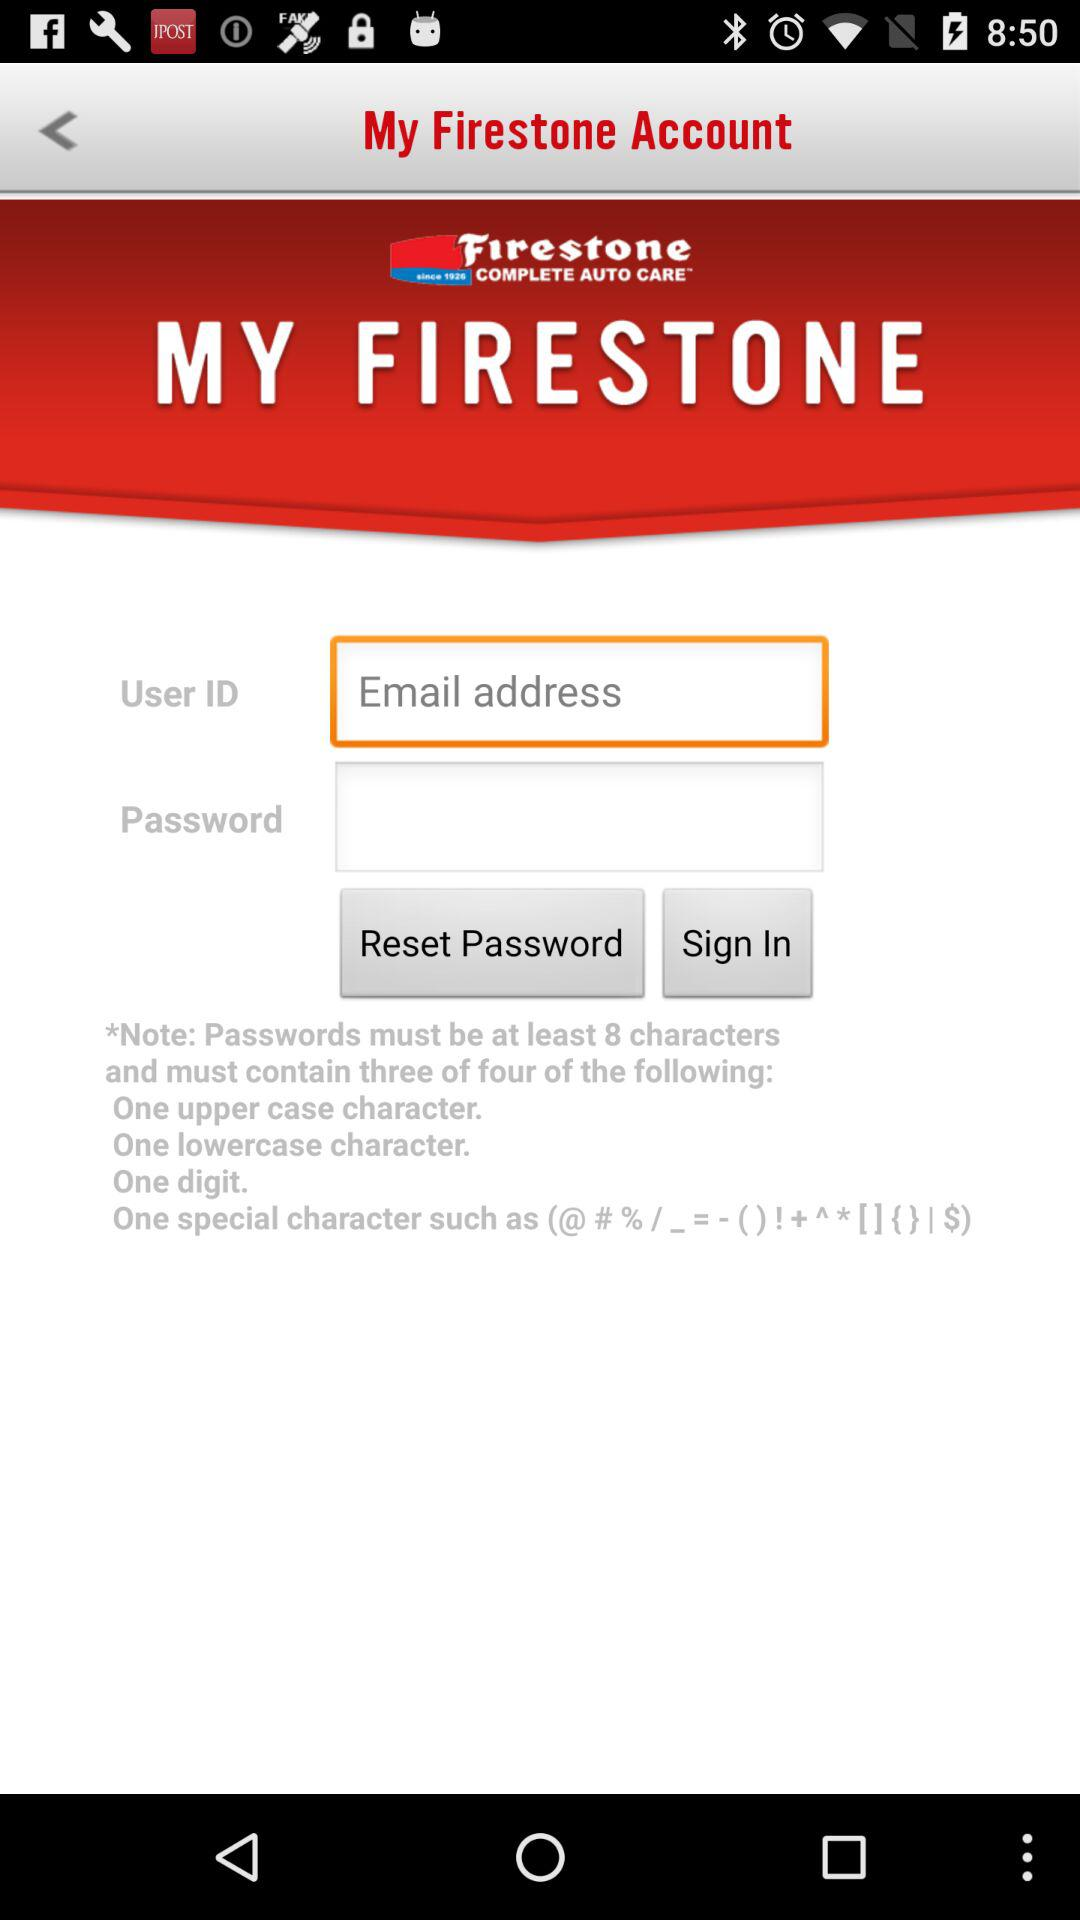What is the name of the application? The name of the application is "Firestone". 